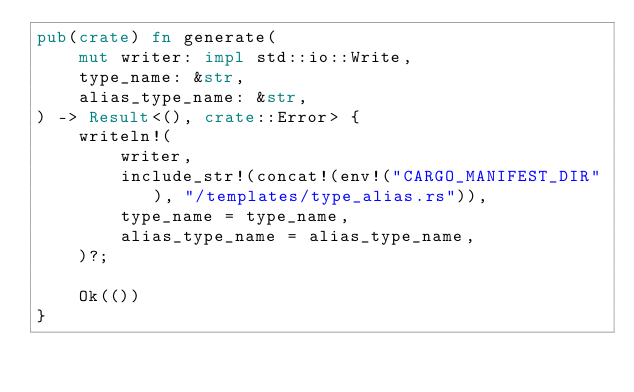<code> <loc_0><loc_0><loc_500><loc_500><_Rust_>pub(crate) fn generate(
	mut writer: impl std::io::Write,
	type_name: &str,
	alias_type_name: &str,
) -> Result<(), crate::Error> {
	writeln!(
		writer,
		include_str!(concat!(env!("CARGO_MANIFEST_DIR"), "/templates/type_alias.rs")),
		type_name = type_name,
		alias_type_name = alias_type_name,
	)?;

	Ok(())
}
</code> 